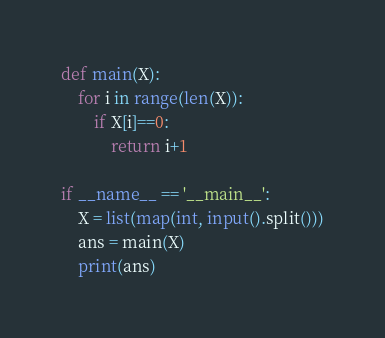Convert code to text. <code><loc_0><loc_0><loc_500><loc_500><_Python_>def main(X):
    for i in range(len(X)):
        if X[i]==0:
            return i+1

if __name__ == '__main__':
    X = list(map(int, input().split()))
    ans = main(X)
    print(ans)

</code> 